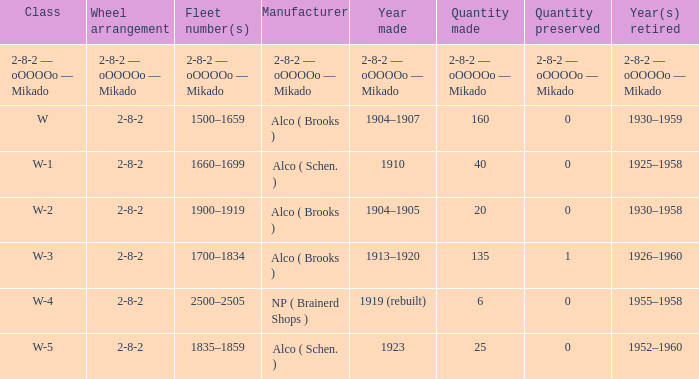Which class had a quantity made of 20? W-2. 